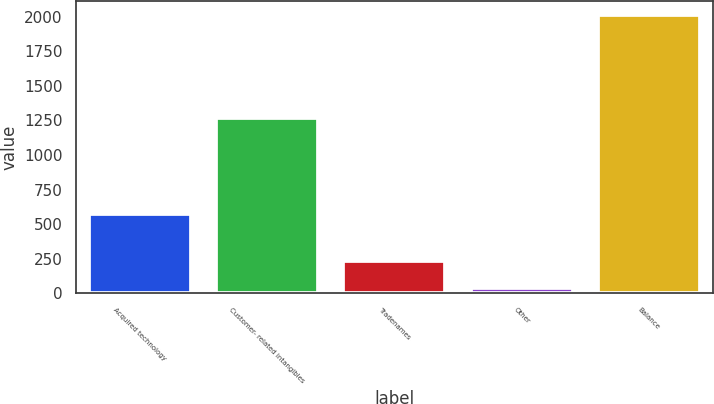<chart> <loc_0><loc_0><loc_500><loc_500><bar_chart><fcel>Acquired technology<fcel>Customer- related intangibles<fcel>Tradenames<fcel>Other<fcel>Balance<nl><fcel>572<fcel>1267<fcel>236.1<fcel>39<fcel>2010<nl></chart> 